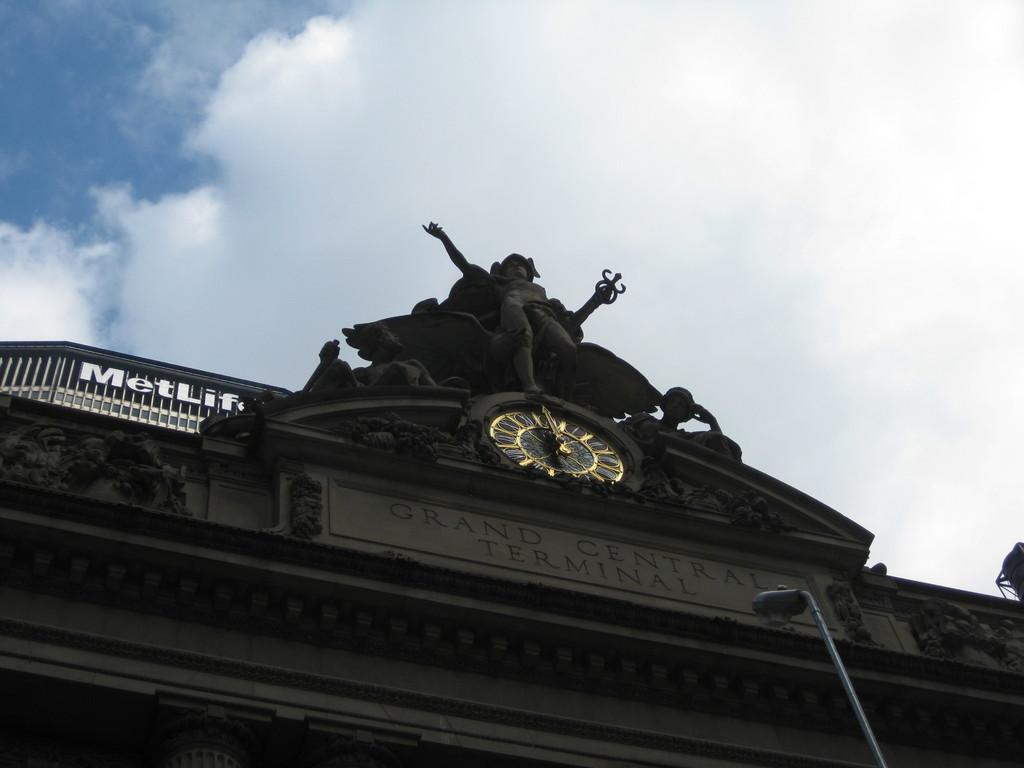<image>
Share a concise interpretation of the image provided. Large statue above a clock and says MetLife on the side. 